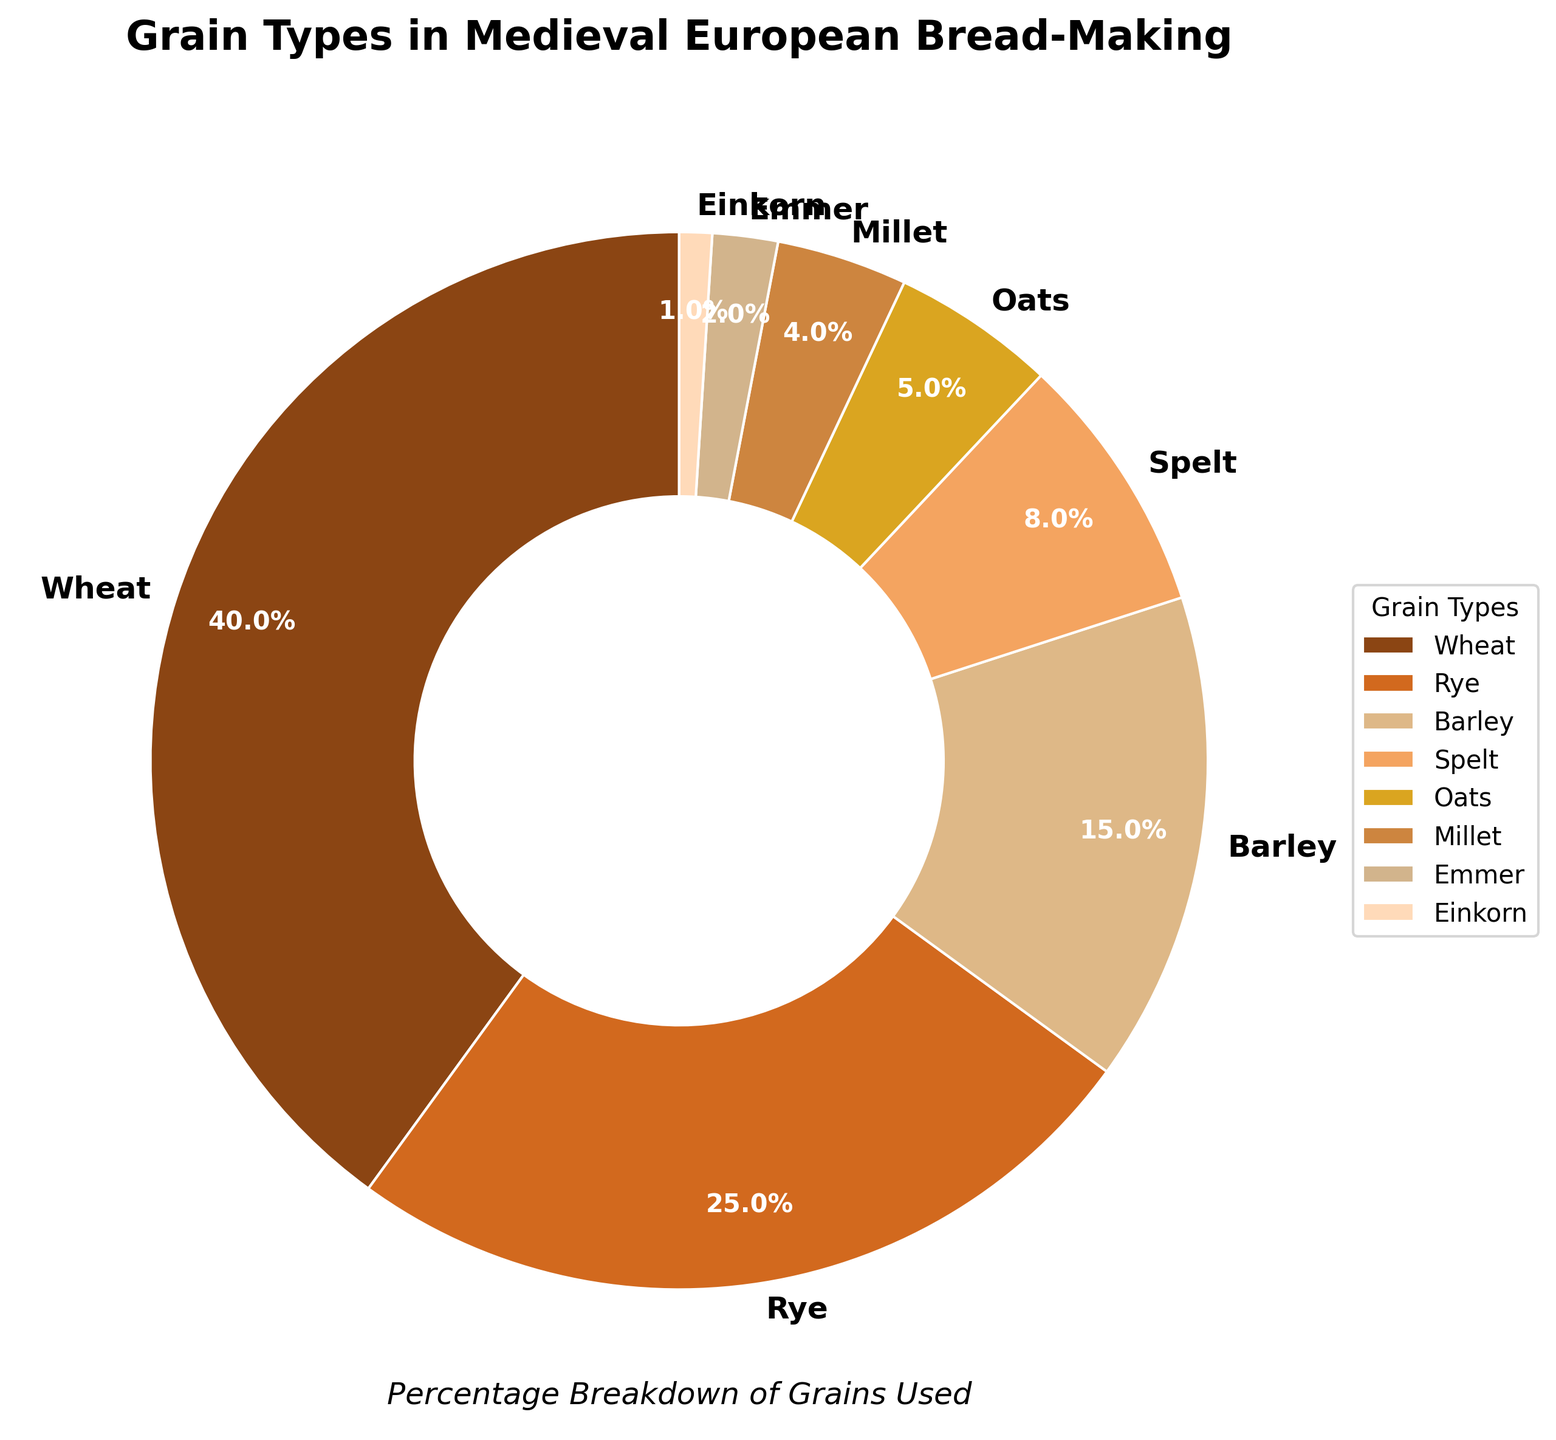What's the combined percentage of the grains that make up less than 10% each? The grains that make up less than 10% are Spelt (8%), Oats (5%), Millet (4%), Emmer (2%), and Einkorn (1%). Adding these percentages gives 8 + 5 + 4 + 2 + 1 = 20%.
Answer: 20% Which grain type has the highest percentage? The grain type with the highest percentage is Wheat, as it takes up 40% of the total.
Answer: Wheat Are there more grains with a percentage greater than or equal to 10% or less than 10%? Grains with a percentage greater than or equal to 10% are Wheat (40%), Rye (25%), and Barley (15%). This gives 3 grains. Grains with a percentage less than 10% are Spelt (8%), Oats (5%), Millet (4%), Emmer (2%), and Einkorn (1%). This gives 5 grains. Therefore, there are more grains with a percentage less than 10%.
Answer: Less than 10% What is the difference in percentage between the grain type with the highest usage and the grain type with the second highest usage? The grain type with the highest usage is Wheat (40%). The grain type with the second highest usage is Rye (25%). The difference in percentage is 40% - 25% = 15%.
Answer: 15% Which grain types together make up more than half of the total percentage? The grains that together make up more than 50% include Wheat (40%) and Rye (25%). Adding these gives 40 + 25 = 65%, which is more than half of the total percentage.
Answer: Wheat and Rye How does the percentage of Barley compare to the percentage of Oats? The percentage of Barley is 15%, while the percentage of Oats is 5%. Barley has a higher percentage than Oats.
Answer: Barley > Oats If you combine the percentages of Rye and Barley, does it exceed the percentage of Wheat? The percentage of Rye is 25% and Barley is 15%. Combined, they make 25 + 15 = 40%. This does not exceed the percentage of Wheat, which is also 40%.
Answer: No How many grain types have a percentage below 5%? The grain types with a percentage below 5% are Millet (4%), Emmer (2%), and Einkorn (1%). There are 3 grain types in total.
Answer: 3 